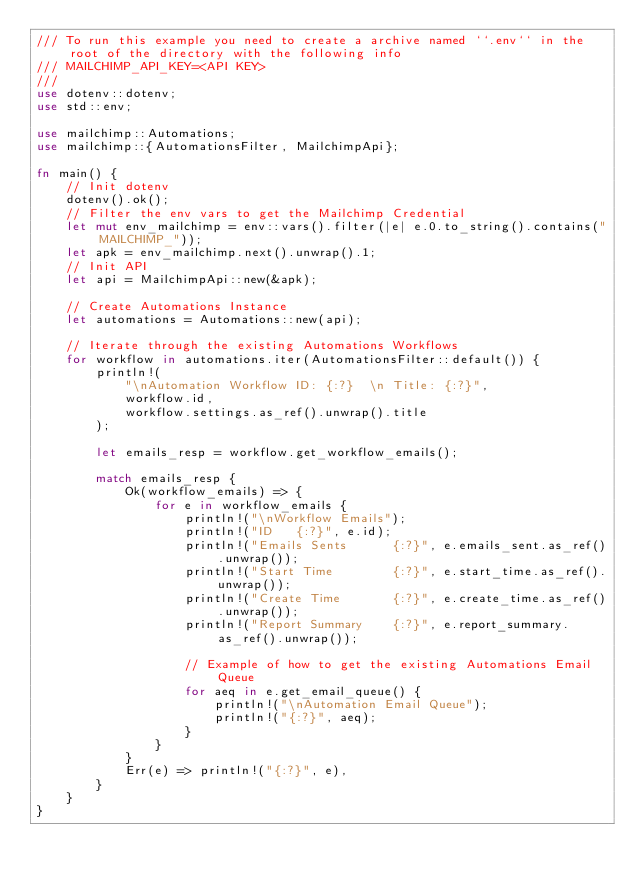<code> <loc_0><loc_0><loc_500><loc_500><_Rust_>/// To run this example you need to create a archive named ``.env`` in the root of the directory with the following info
/// MAILCHIMP_API_KEY=<API KEY>
///
use dotenv::dotenv;
use std::env;

use mailchimp::Automations;
use mailchimp::{AutomationsFilter, MailchimpApi};

fn main() {
    // Init dotenv
    dotenv().ok();
    // Filter the env vars to get the Mailchimp Credential
    let mut env_mailchimp = env::vars().filter(|e| e.0.to_string().contains("MAILCHIMP_"));
    let apk = env_mailchimp.next().unwrap().1;
    // Init API
    let api = MailchimpApi::new(&apk);

    // Create Automations Instance
    let automations = Automations::new(api);

    // Iterate through the existing Automations Workflows
    for workflow in automations.iter(AutomationsFilter::default()) {
        println!(
            "\nAutomation Workflow ID: {:?}  \n Title: {:?}",
            workflow.id,
            workflow.settings.as_ref().unwrap().title
        );

        let emails_resp = workflow.get_workflow_emails();

        match emails_resp {
            Ok(workflow_emails) => {
                for e in workflow_emails {
                    println!("\nWorkflow Emails");
                    println!("ID   {:?}", e.id);
                    println!("Emails Sents      {:?}", e.emails_sent.as_ref().unwrap());
                    println!("Start Time        {:?}", e.start_time.as_ref().unwrap());
                    println!("Create Time       {:?}", e.create_time.as_ref().unwrap());
                    println!("Report Summary    {:?}", e.report_summary.as_ref().unwrap());

                    // Example of how to get the existing Automations Email Queue
                    for aeq in e.get_email_queue() {
                        println!("\nAutomation Email Queue");
                        println!("{:?}", aeq);
                    }
                }
            }
            Err(e) => println!("{:?}", e),
        }
    }
}
</code> 